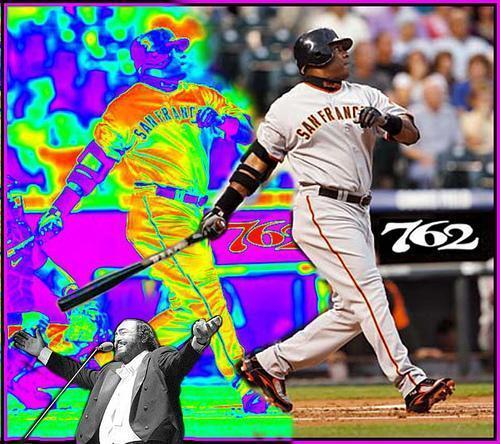How many people are there?
Give a very brief answer. 6. 